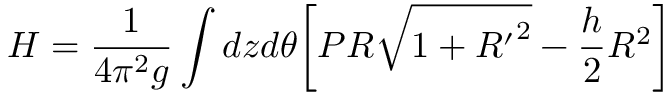Convert formula to latex. <formula><loc_0><loc_0><loc_500><loc_500>H = \frac { 1 } { 4 \pi ^ { 2 } g } \int d z d \theta \left [ P R \sqrt { 1 + { R ^ { \prime } } ^ { 2 } } - \frac { h } { 2 } R ^ { 2 } \right ]</formula> 